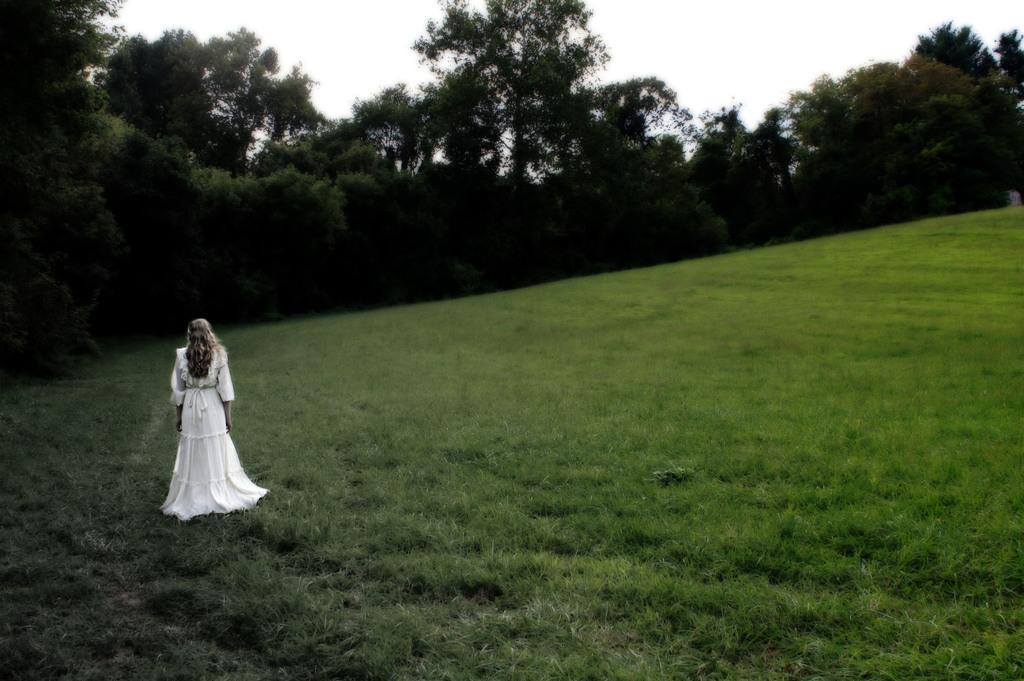What type of landscape is depicted in the image? There is a grassland in the image. Who or what can be seen on the grassland? There is a lady standing on the grassland. What can be seen in the distance behind the lady? There are trees in the background of the image. What is visible above the trees and lady in the image? The sky is visible in the background of the image. What type of form is the lady holding in the image? There is no form visible in the image; the lady is simply standing on the grassland. Can you see a bike in the image? No, there is no bike present in the image. 